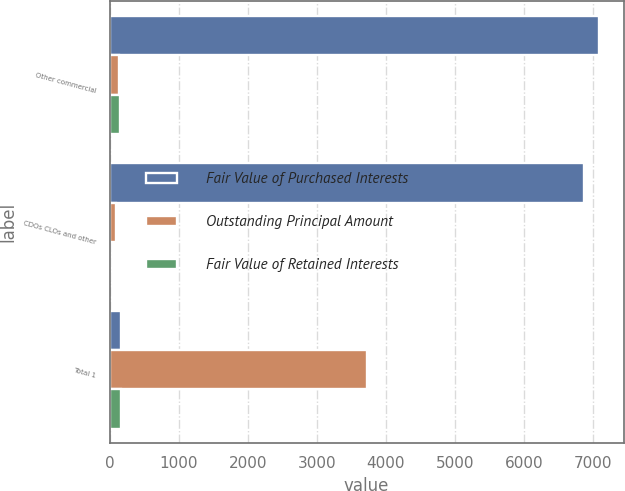Convert chart. <chart><loc_0><loc_0><loc_500><loc_500><stacked_bar_chart><ecel><fcel>Other commercial<fcel>CDOs CLOs and other<fcel>Total 1<nl><fcel>Fair Value of Purchased Interests<fcel>7087<fcel>6861<fcel>157<nl><fcel>Outstanding Principal Amount<fcel>140<fcel>86<fcel>3727<nl><fcel>Fair Value of Retained Interests<fcel>153<fcel>8<fcel>161<nl></chart> 